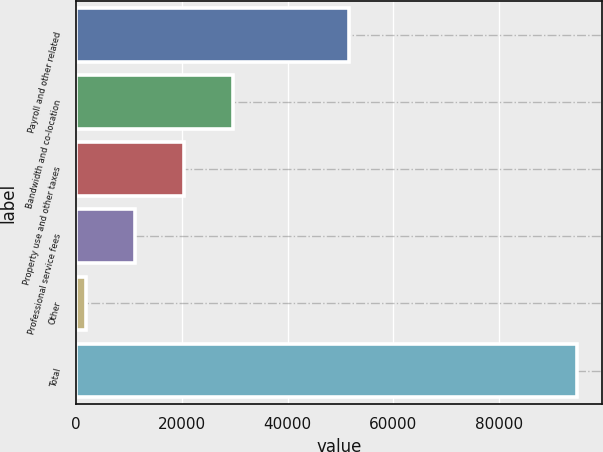<chart> <loc_0><loc_0><loc_500><loc_500><bar_chart><fcel>Payroll and other related<fcel>Bandwidth and co-location<fcel>Property use and other taxes<fcel>Professional service fees<fcel>Other<fcel>Total<nl><fcel>51591<fcel>29634.5<fcel>20345<fcel>11055.5<fcel>1766<fcel>94661<nl></chart> 